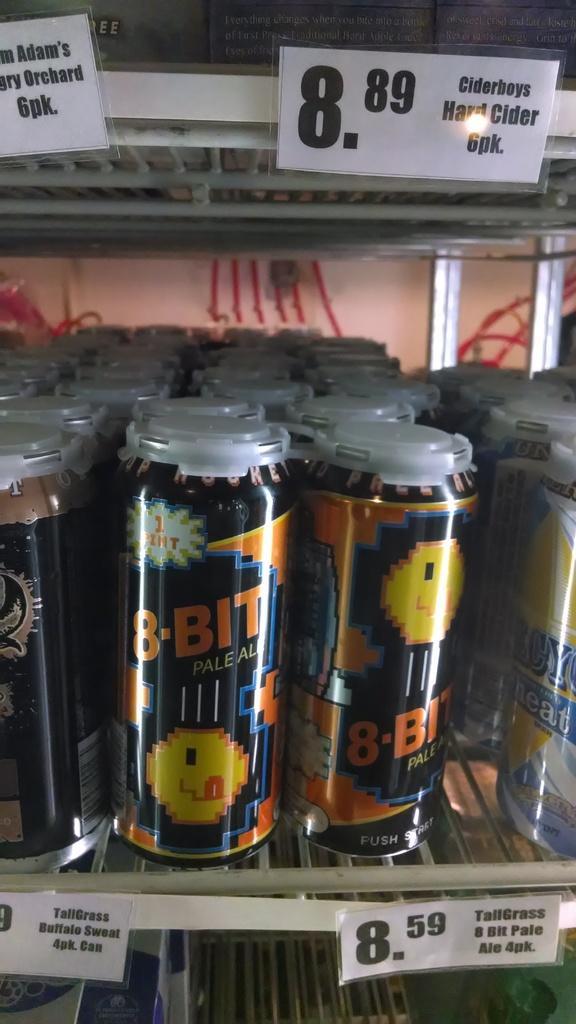In one or two sentences, can you explain what this image depicts? In the foreground of this picture, there are many tins in the rack and price tags attached to it. 